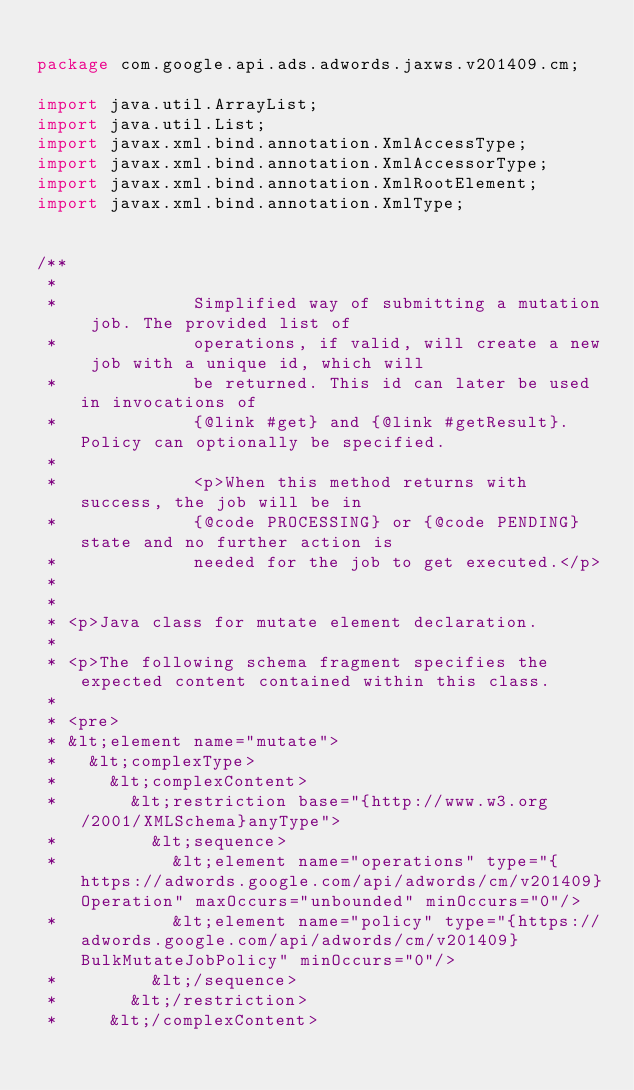Convert code to text. <code><loc_0><loc_0><loc_500><loc_500><_Java_>
package com.google.api.ads.adwords.jaxws.v201409.cm;

import java.util.ArrayList;
import java.util.List;
import javax.xml.bind.annotation.XmlAccessType;
import javax.xml.bind.annotation.XmlAccessorType;
import javax.xml.bind.annotation.XmlRootElement;
import javax.xml.bind.annotation.XmlType;


/**
 * 
 *             Simplified way of submitting a mutation job. The provided list of
 *             operations, if valid, will create a new job with a unique id, which will
 *             be returned. This id can later be used in invocations of
 *             {@link #get} and {@link #getResult}. Policy can optionally be specified.
 *             
 *             <p>When this method returns with success, the job will be in
 *             {@code PROCESSING} or {@code PENDING} state and no further action is
 *             needed for the job to get executed.</p>
 *           
 * 
 * <p>Java class for mutate element declaration.
 * 
 * <p>The following schema fragment specifies the expected content contained within this class.
 * 
 * <pre>
 * &lt;element name="mutate">
 *   &lt;complexType>
 *     &lt;complexContent>
 *       &lt;restriction base="{http://www.w3.org/2001/XMLSchema}anyType">
 *         &lt;sequence>
 *           &lt;element name="operations" type="{https://adwords.google.com/api/adwords/cm/v201409}Operation" maxOccurs="unbounded" minOccurs="0"/>
 *           &lt;element name="policy" type="{https://adwords.google.com/api/adwords/cm/v201409}BulkMutateJobPolicy" minOccurs="0"/>
 *         &lt;/sequence>
 *       &lt;/restriction>
 *     &lt;/complexContent></code> 